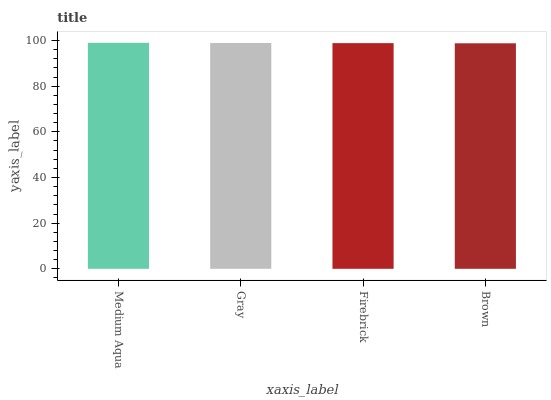Is Brown the minimum?
Answer yes or no. Yes. Is Medium Aqua the maximum?
Answer yes or no. Yes. Is Gray the minimum?
Answer yes or no. No. Is Gray the maximum?
Answer yes or no. No. Is Medium Aqua greater than Gray?
Answer yes or no. Yes. Is Gray less than Medium Aqua?
Answer yes or no. Yes. Is Gray greater than Medium Aqua?
Answer yes or no. No. Is Medium Aqua less than Gray?
Answer yes or no. No. Is Gray the high median?
Answer yes or no. Yes. Is Firebrick the low median?
Answer yes or no. Yes. Is Brown the high median?
Answer yes or no. No. Is Medium Aqua the low median?
Answer yes or no. No. 